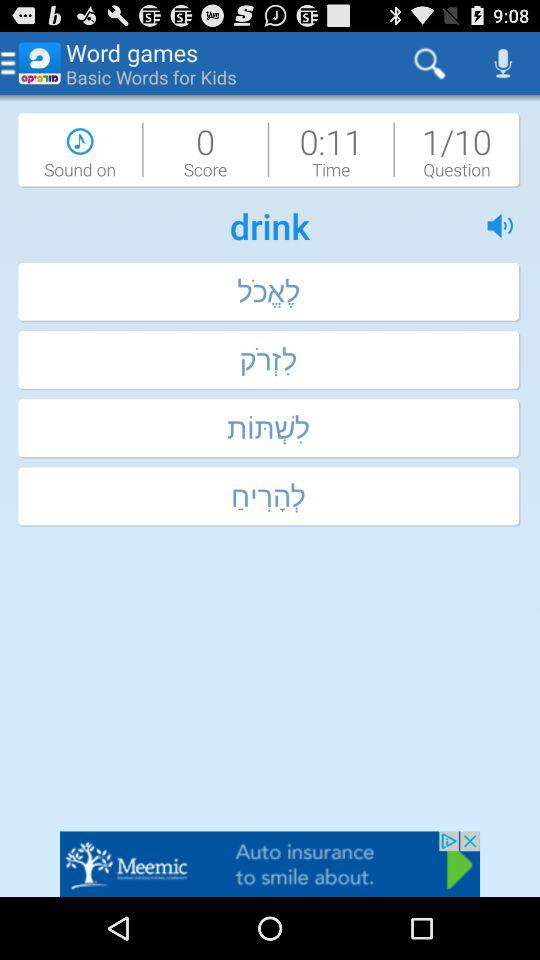Which question number are we currently on? You are currently on question number 1. 